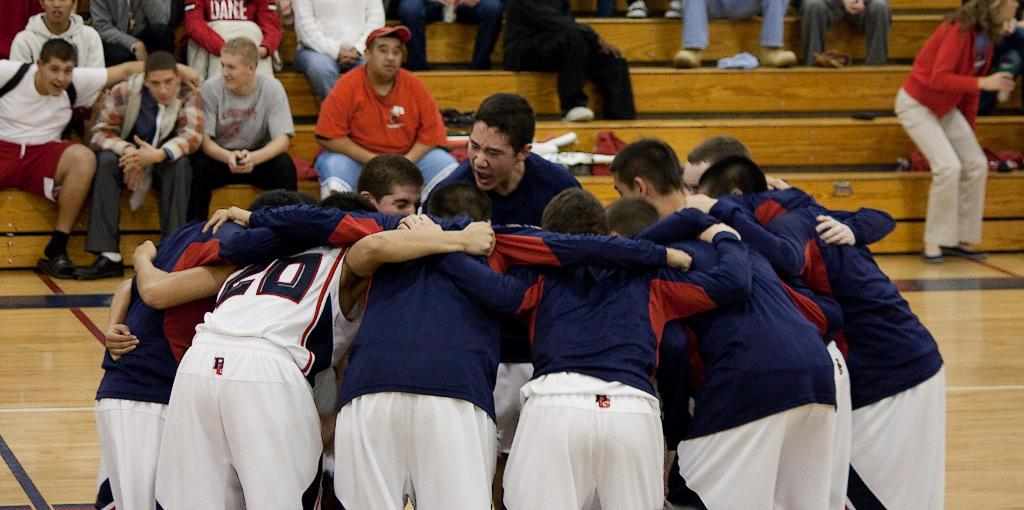What is happening in the image involving a group of people? There is a group of people standing together in the image. Where are the people standing? The group of people is standing on the floor. What other feature can be seen in the image? There are stairs visible in the image. What are the people on the stairs doing? There is another group of people sitting on the stairs. What advice is being given in the image? There is no indication in the image that anyone is giving advice. 